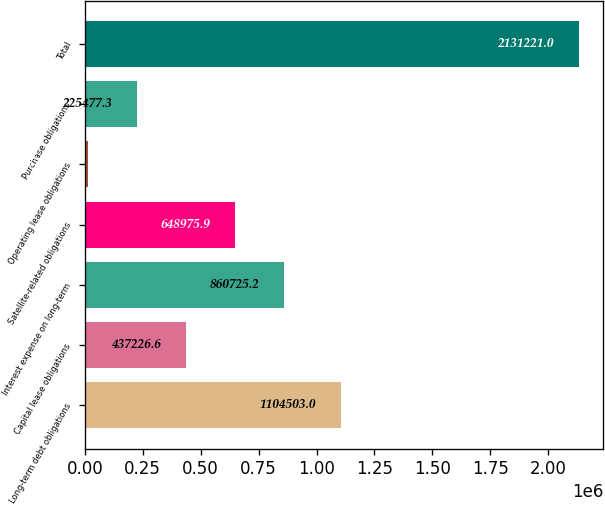Convert chart. <chart><loc_0><loc_0><loc_500><loc_500><bar_chart><fcel>Long-term debt obligations<fcel>Capital lease obligations<fcel>Interest expense on long-term<fcel>Satellite-related obligations<fcel>Operating lease obligations<fcel>Purchase obligations<fcel>Total<nl><fcel>1.1045e+06<fcel>437227<fcel>860725<fcel>648976<fcel>13728<fcel>225477<fcel>2.13122e+06<nl></chart> 